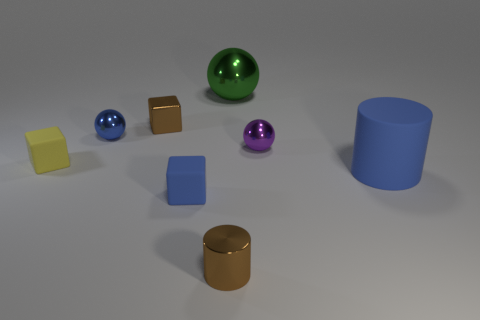How many other things are there of the same color as the large rubber object?
Ensure brevity in your answer.  2. There is a cube that is in front of the yellow thing; what color is it?
Offer a very short reply. Blue. How many blue things are big objects or matte cylinders?
Provide a short and direct response. 1. The matte cylinder is what color?
Provide a short and direct response. Blue. Are there fewer tiny metallic things left of the small yellow rubber thing than small cubes on the left side of the tiny purple shiny object?
Offer a very short reply. Yes. There is a thing that is behind the yellow object and right of the green thing; what is its shape?
Ensure brevity in your answer.  Sphere. What number of green shiny things are the same shape as the blue shiny thing?
Give a very brief answer. 1. What size is the brown block that is made of the same material as the large green sphere?
Offer a very short reply. Small. What number of objects have the same size as the metallic cylinder?
Keep it short and to the point. 5. There is a tiny metal sphere to the right of the metal object that is in front of the big rubber thing; what color is it?
Provide a short and direct response. Purple. 